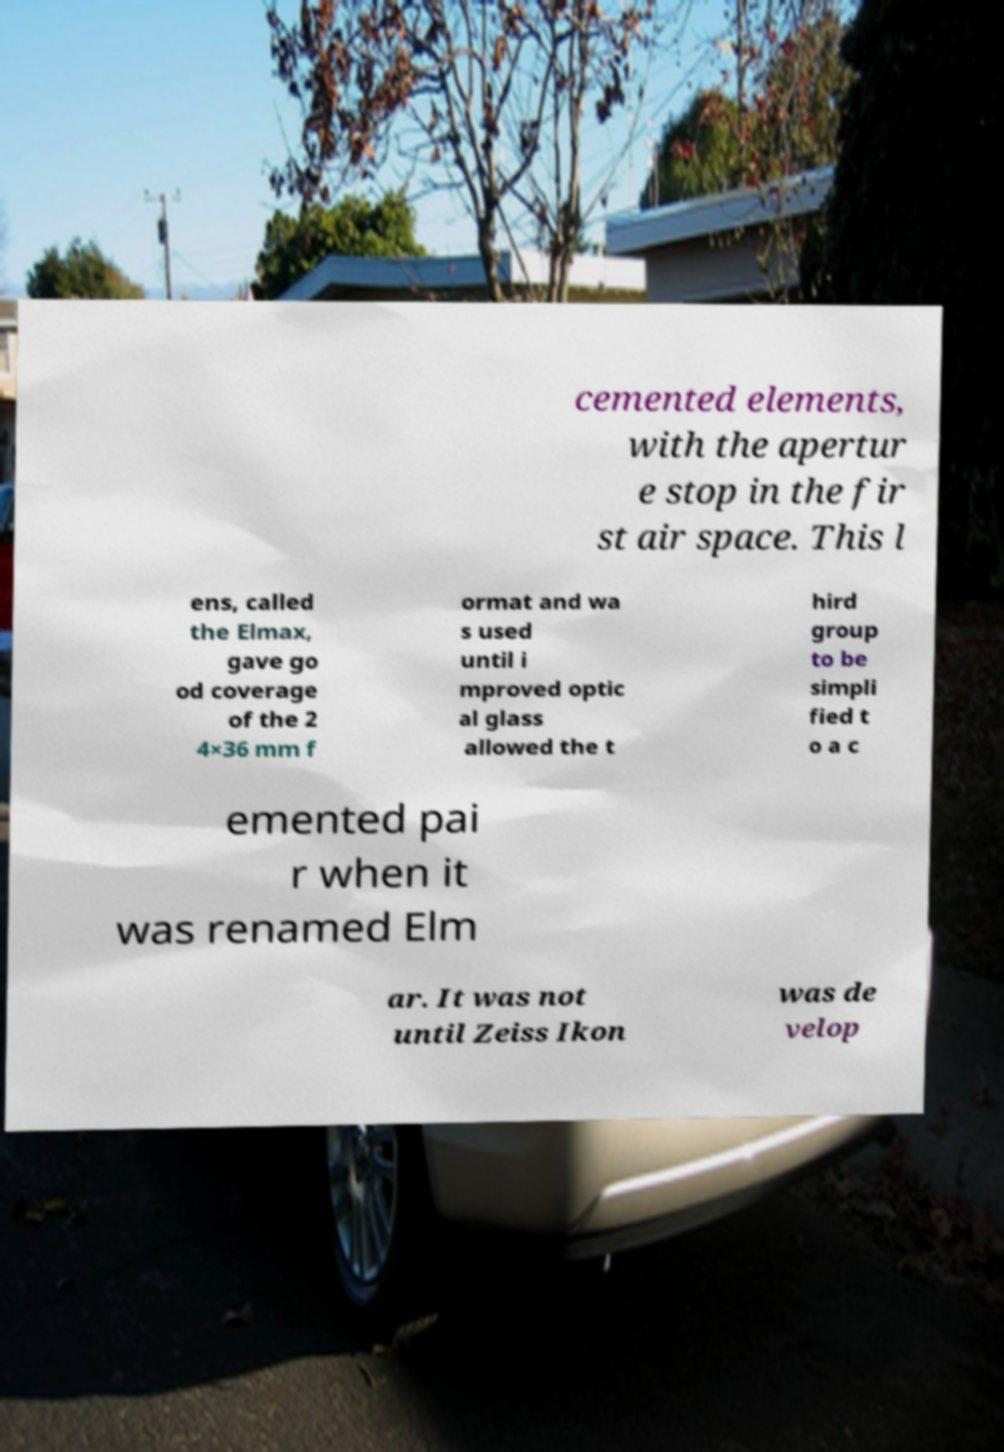I need the written content from this picture converted into text. Can you do that? cemented elements, with the apertur e stop in the fir st air space. This l ens, called the Elmax, gave go od coverage of the 2 4×36 mm f ormat and wa s used until i mproved optic al glass allowed the t hird group to be simpli fied t o a c emented pai r when it was renamed Elm ar. It was not until Zeiss Ikon was de velop 